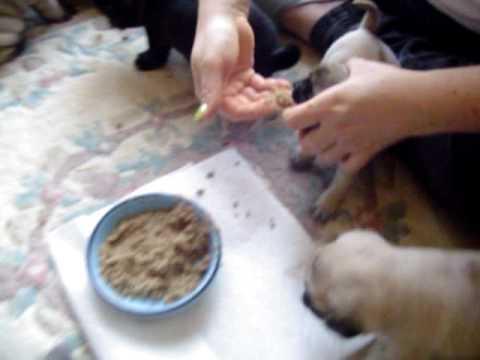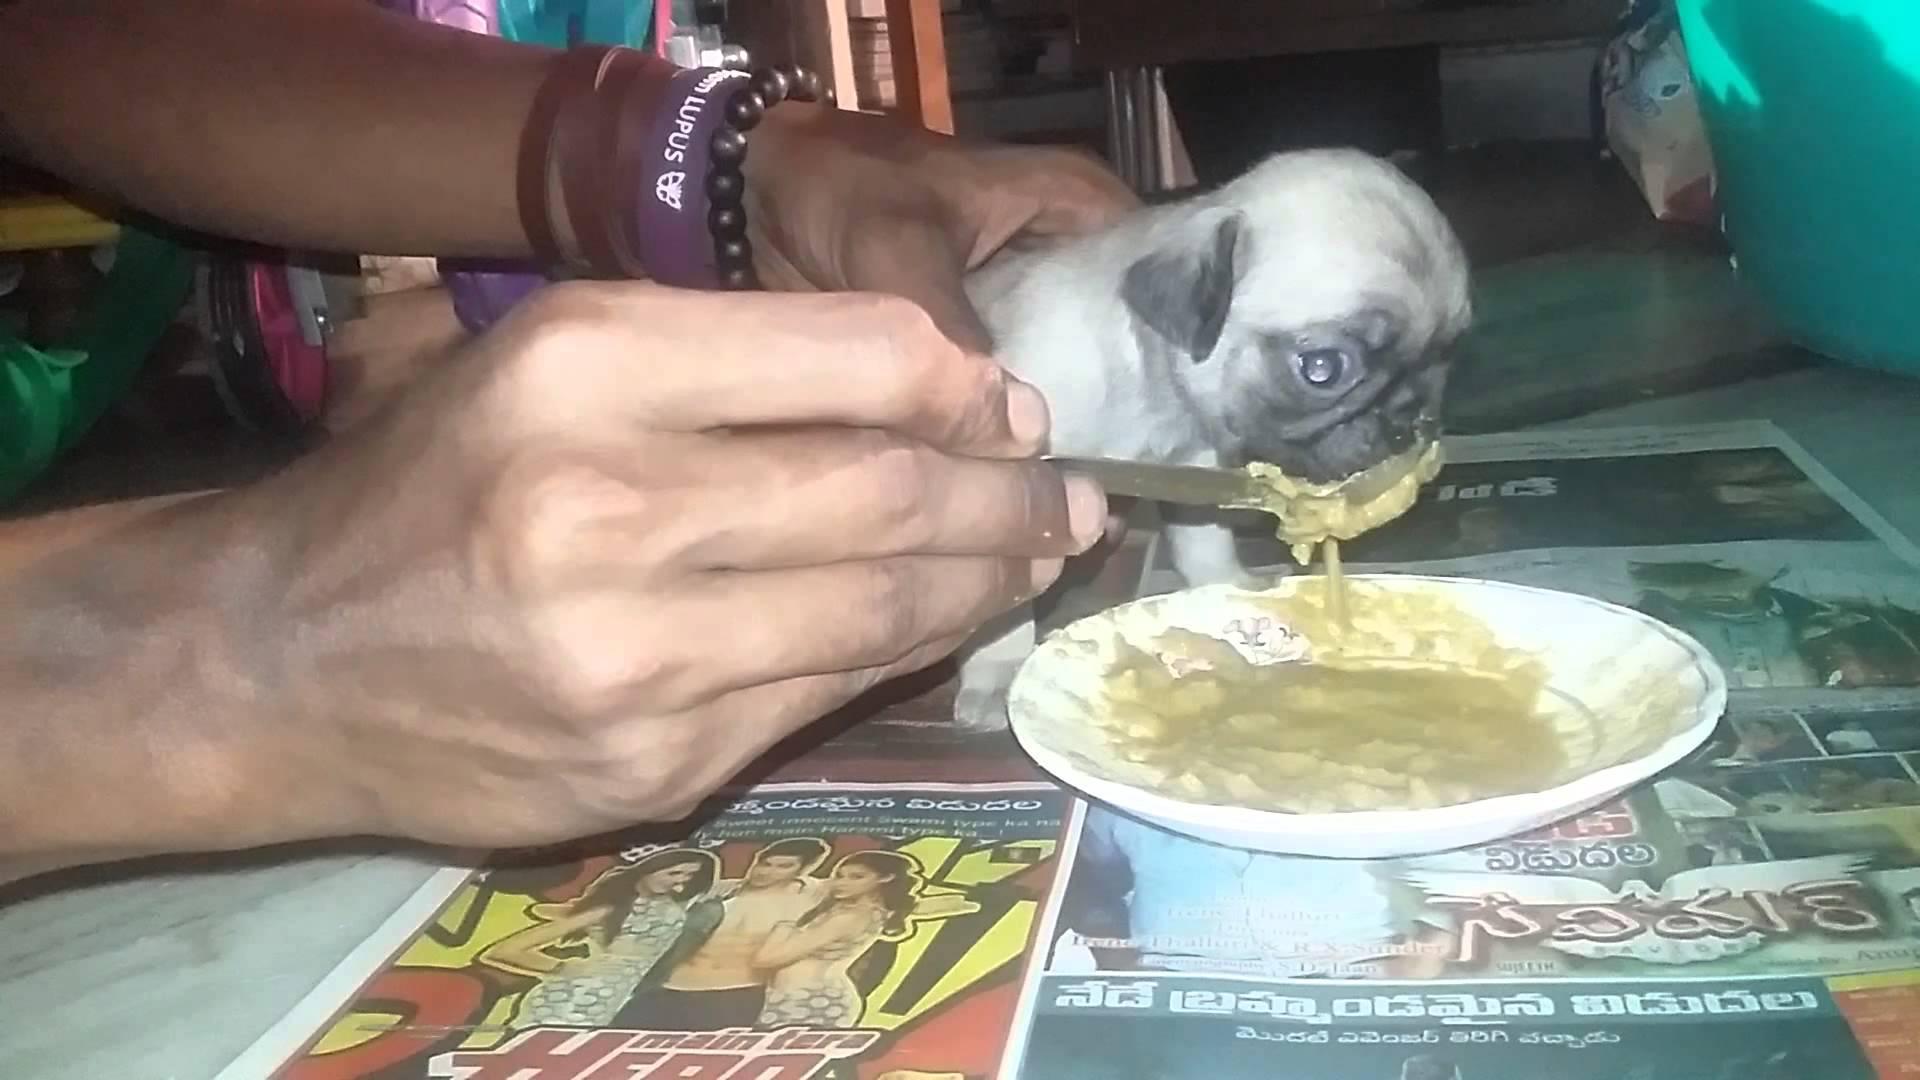The first image is the image on the left, the second image is the image on the right. Given the left and right images, does the statement "Someone is feeding a puppy with a baby bottle in one image, and the other image contains one 'real' pug dog." hold true? Answer yes or no. No. The first image is the image on the left, the second image is the image on the right. For the images displayed, is the sentence "In one of the images you can see someone feeding a puppy from a bottle." factually correct? Answer yes or no. No. 